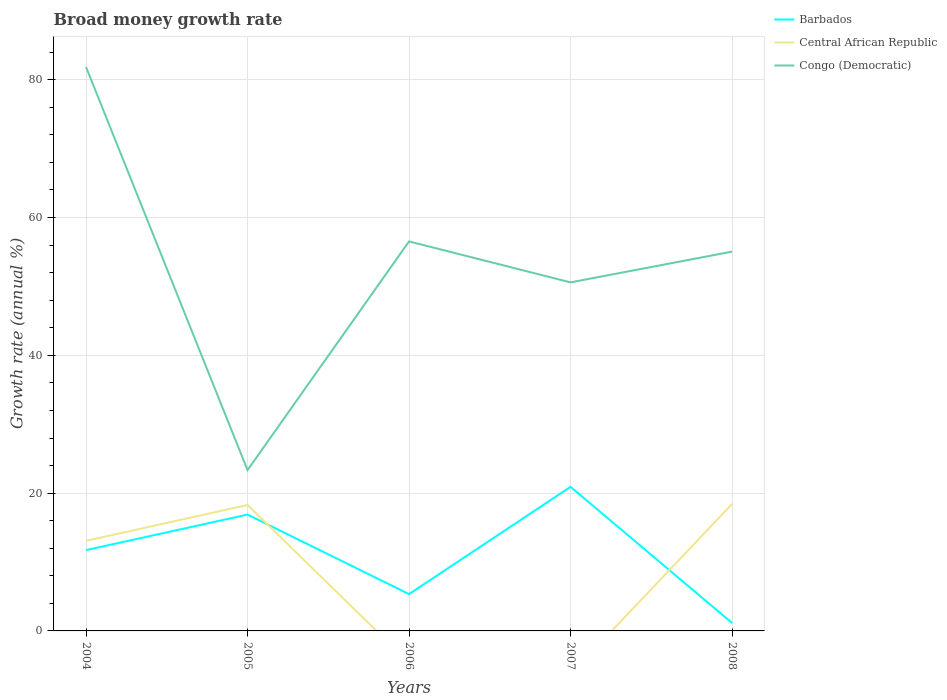How many different coloured lines are there?
Give a very brief answer. 3. Is the number of lines equal to the number of legend labels?
Keep it short and to the point. No. What is the total growth rate in Congo (Democratic) in the graph?
Offer a terse response. -27.25. What is the difference between the highest and the second highest growth rate in Congo (Democratic)?
Provide a succinct answer. 58.51. What is the difference between the highest and the lowest growth rate in Barbados?
Give a very brief answer. 3. Is the growth rate in Barbados strictly greater than the growth rate in Congo (Democratic) over the years?
Offer a very short reply. Yes. How many years are there in the graph?
Ensure brevity in your answer.  5. What is the difference between two consecutive major ticks on the Y-axis?
Your response must be concise. 20. Are the values on the major ticks of Y-axis written in scientific E-notation?
Offer a terse response. No. Does the graph contain any zero values?
Provide a short and direct response. Yes. Does the graph contain grids?
Your answer should be very brief. Yes. Where does the legend appear in the graph?
Your answer should be very brief. Top right. How many legend labels are there?
Give a very brief answer. 3. What is the title of the graph?
Offer a very short reply. Broad money growth rate. Does "Malaysia" appear as one of the legend labels in the graph?
Your response must be concise. No. What is the label or title of the Y-axis?
Make the answer very short. Growth rate (annual %). What is the Growth rate (annual %) in Barbados in 2004?
Keep it short and to the point. 11.73. What is the Growth rate (annual %) in Central African Republic in 2004?
Offer a terse response. 13.07. What is the Growth rate (annual %) in Congo (Democratic) in 2004?
Your response must be concise. 81.85. What is the Growth rate (annual %) in Barbados in 2005?
Give a very brief answer. 16.89. What is the Growth rate (annual %) of Central African Republic in 2005?
Your answer should be very brief. 18.28. What is the Growth rate (annual %) in Congo (Democratic) in 2005?
Keep it short and to the point. 23.34. What is the Growth rate (annual %) in Barbados in 2006?
Keep it short and to the point. 5.35. What is the Growth rate (annual %) of Congo (Democratic) in 2006?
Your answer should be compact. 56.53. What is the Growth rate (annual %) in Barbados in 2007?
Make the answer very short. 20.91. What is the Growth rate (annual %) of Central African Republic in 2007?
Give a very brief answer. 0. What is the Growth rate (annual %) in Congo (Democratic) in 2007?
Offer a terse response. 50.59. What is the Growth rate (annual %) in Barbados in 2008?
Provide a succinct answer. 1.15. What is the Growth rate (annual %) in Central African Republic in 2008?
Make the answer very short. 18.43. What is the Growth rate (annual %) of Congo (Democratic) in 2008?
Your response must be concise. 55.05. Across all years, what is the maximum Growth rate (annual %) of Barbados?
Offer a very short reply. 20.91. Across all years, what is the maximum Growth rate (annual %) in Central African Republic?
Your response must be concise. 18.43. Across all years, what is the maximum Growth rate (annual %) in Congo (Democratic)?
Provide a short and direct response. 81.85. Across all years, what is the minimum Growth rate (annual %) in Barbados?
Provide a short and direct response. 1.15. Across all years, what is the minimum Growth rate (annual %) in Central African Republic?
Make the answer very short. 0. Across all years, what is the minimum Growth rate (annual %) of Congo (Democratic)?
Provide a short and direct response. 23.34. What is the total Growth rate (annual %) of Barbados in the graph?
Make the answer very short. 56.03. What is the total Growth rate (annual %) of Central African Republic in the graph?
Provide a short and direct response. 49.79. What is the total Growth rate (annual %) of Congo (Democratic) in the graph?
Provide a succinct answer. 267.36. What is the difference between the Growth rate (annual %) in Barbados in 2004 and that in 2005?
Give a very brief answer. -5.16. What is the difference between the Growth rate (annual %) of Central African Republic in 2004 and that in 2005?
Offer a very short reply. -5.21. What is the difference between the Growth rate (annual %) in Congo (Democratic) in 2004 and that in 2005?
Provide a short and direct response. 58.51. What is the difference between the Growth rate (annual %) in Barbados in 2004 and that in 2006?
Ensure brevity in your answer.  6.38. What is the difference between the Growth rate (annual %) of Congo (Democratic) in 2004 and that in 2006?
Provide a short and direct response. 25.32. What is the difference between the Growth rate (annual %) of Barbados in 2004 and that in 2007?
Make the answer very short. -9.18. What is the difference between the Growth rate (annual %) of Congo (Democratic) in 2004 and that in 2007?
Make the answer very short. 31.27. What is the difference between the Growth rate (annual %) in Barbados in 2004 and that in 2008?
Provide a short and direct response. 10.58. What is the difference between the Growth rate (annual %) in Central African Republic in 2004 and that in 2008?
Ensure brevity in your answer.  -5.35. What is the difference between the Growth rate (annual %) in Congo (Democratic) in 2004 and that in 2008?
Your response must be concise. 26.8. What is the difference between the Growth rate (annual %) of Barbados in 2005 and that in 2006?
Give a very brief answer. 11.54. What is the difference between the Growth rate (annual %) in Congo (Democratic) in 2005 and that in 2006?
Ensure brevity in your answer.  -33.19. What is the difference between the Growth rate (annual %) in Barbados in 2005 and that in 2007?
Provide a succinct answer. -4.03. What is the difference between the Growth rate (annual %) in Congo (Democratic) in 2005 and that in 2007?
Make the answer very short. -27.25. What is the difference between the Growth rate (annual %) in Barbados in 2005 and that in 2008?
Provide a short and direct response. 15.73. What is the difference between the Growth rate (annual %) in Central African Republic in 2005 and that in 2008?
Your answer should be very brief. -0.14. What is the difference between the Growth rate (annual %) in Congo (Democratic) in 2005 and that in 2008?
Keep it short and to the point. -31.71. What is the difference between the Growth rate (annual %) in Barbados in 2006 and that in 2007?
Keep it short and to the point. -15.57. What is the difference between the Growth rate (annual %) of Congo (Democratic) in 2006 and that in 2007?
Ensure brevity in your answer.  5.94. What is the difference between the Growth rate (annual %) in Barbados in 2006 and that in 2008?
Your answer should be compact. 4.19. What is the difference between the Growth rate (annual %) in Congo (Democratic) in 2006 and that in 2008?
Provide a short and direct response. 1.48. What is the difference between the Growth rate (annual %) in Barbados in 2007 and that in 2008?
Keep it short and to the point. 19.76. What is the difference between the Growth rate (annual %) of Congo (Democratic) in 2007 and that in 2008?
Make the answer very short. -4.46. What is the difference between the Growth rate (annual %) in Barbados in 2004 and the Growth rate (annual %) in Central African Republic in 2005?
Keep it short and to the point. -6.55. What is the difference between the Growth rate (annual %) in Barbados in 2004 and the Growth rate (annual %) in Congo (Democratic) in 2005?
Ensure brevity in your answer.  -11.61. What is the difference between the Growth rate (annual %) in Central African Republic in 2004 and the Growth rate (annual %) in Congo (Democratic) in 2005?
Provide a short and direct response. -10.27. What is the difference between the Growth rate (annual %) in Barbados in 2004 and the Growth rate (annual %) in Congo (Democratic) in 2006?
Your answer should be compact. -44.8. What is the difference between the Growth rate (annual %) in Central African Republic in 2004 and the Growth rate (annual %) in Congo (Democratic) in 2006?
Provide a short and direct response. -43.46. What is the difference between the Growth rate (annual %) in Barbados in 2004 and the Growth rate (annual %) in Congo (Democratic) in 2007?
Make the answer very short. -38.86. What is the difference between the Growth rate (annual %) in Central African Republic in 2004 and the Growth rate (annual %) in Congo (Democratic) in 2007?
Your answer should be compact. -37.51. What is the difference between the Growth rate (annual %) of Barbados in 2004 and the Growth rate (annual %) of Central African Republic in 2008?
Give a very brief answer. -6.7. What is the difference between the Growth rate (annual %) of Barbados in 2004 and the Growth rate (annual %) of Congo (Democratic) in 2008?
Offer a terse response. -43.32. What is the difference between the Growth rate (annual %) in Central African Republic in 2004 and the Growth rate (annual %) in Congo (Democratic) in 2008?
Provide a succinct answer. -41.98. What is the difference between the Growth rate (annual %) of Barbados in 2005 and the Growth rate (annual %) of Congo (Democratic) in 2006?
Provide a short and direct response. -39.64. What is the difference between the Growth rate (annual %) in Central African Republic in 2005 and the Growth rate (annual %) in Congo (Democratic) in 2006?
Your response must be concise. -38.25. What is the difference between the Growth rate (annual %) in Barbados in 2005 and the Growth rate (annual %) in Congo (Democratic) in 2007?
Offer a terse response. -33.7. What is the difference between the Growth rate (annual %) of Central African Republic in 2005 and the Growth rate (annual %) of Congo (Democratic) in 2007?
Provide a short and direct response. -32.3. What is the difference between the Growth rate (annual %) in Barbados in 2005 and the Growth rate (annual %) in Central African Republic in 2008?
Offer a very short reply. -1.54. What is the difference between the Growth rate (annual %) in Barbados in 2005 and the Growth rate (annual %) in Congo (Democratic) in 2008?
Make the answer very short. -38.16. What is the difference between the Growth rate (annual %) in Central African Republic in 2005 and the Growth rate (annual %) in Congo (Democratic) in 2008?
Provide a succinct answer. -36.77. What is the difference between the Growth rate (annual %) of Barbados in 2006 and the Growth rate (annual %) of Congo (Democratic) in 2007?
Give a very brief answer. -45.24. What is the difference between the Growth rate (annual %) of Barbados in 2006 and the Growth rate (annual %) of Central African Republic in 2008?
Ensure brevity in your answer.  -13.08. What is the difference between the Growth rate (annual %) of Barbados in 2006 and the Growth rate (annual %) of Congo (Democratic) in 2008?
Keep it short and to the point. -49.71. What is the difference between the Growth rate (annual %) of Barbados in 2007 and the Growth rate (annual %) of Central African Republic in 2008?
Your answer should be very brief. 2.48. What is the difference between the Growth rate (annual %) in Barbados in 2007 and the Growth rate (annual %) in Congo (Democratic) in 2008?
Make the answer very short. -34.14. What is the average Growth rate (annual %) in Barbados per year?
Your answer should be compact. 11.21. What is the average Growth rate (annual %) in Central African Republic per year?
Give a very brief answer. 9.96. What is the average Growth rate (annual %) in Congo (Democratic) per year?
Give a very brief answer. 53.47. In the year 2004, what is the difference between the Growth rate (annual %) of Barbados and Growth rate (annual %) of Central African Republic?
Ensure brevity in your answer.  -1.35. In the year 2004, what is the difference between the Growth rate (annual %) in Barbados and Growth rate (annual %) in Congo (Democratic)?
Offer a very short reply. -70.12. In the year 2004, what is the difference between the Growth rate (annual %) of Central African Republic and Growth rate (annual %) of Congo (Democratic)?
Make the answer very short. -68.78. In the year 2005, what is the difference between the Growth rate (annual %) of Barbados and Growth rate (annual %) of Central African Republic?
Give a very brief answer. -1.4. In the year 2005, what is the difference between the Growth rate (annual %) in Barbados and Growth rate (annual %) in Congo (Democratic)?
Your answer should be compact. -6.46. In the year 2005, what is the difference between the Growth rate (annual %) of Central African Republic and Growth rate (annual %) of Congo (Democratic)?
Ensure brevity in your answer.  -5.06. In the year 2006, what is the difference between the Growth rate (annual %) in Barbados and Growth rate (annual %) in Congo (Democratic)?
Your answer should be compact. -51.19. In the year 2007, what is the difference between the Growth rate (annual %) in Barbados and Growth rate (annual %) in Congo (Democratic)?
Your answer should be compact. -29.67. In the year 2008, what is the difference between the Growth rate (annual %) of Barbados and Growth rate (annual %) of Central African Republic?
Keep it short and to the point. -17.27. In the year 2008, what is the difference between the Growth rate (annual %) in Barbados and Growth rate (annual %) in Congo (Democratic)?
Your answer should be very brief. -53.9. In the year 2008, what is the difference between the Growth rate (annual %) in Central African Republic and Growth rate (annual %) in Congo (Democratic)?
Offer a terse response. -36.62. What is the ratio of the Growth rate (annual %) in Barbados in 2004 to that in 2005?
Your answer should be compact. 0.69. What is the ratio of the Growth rate (annual %) in Central African Republic in 2004 to that in 2005?
Provide a short and direct response. 0.72. What is the ratio of the Growth rate (annual %) of Congo (Democratic) in 2004 to that in 2005?
Make the answer very short. 3.51. What is the ratio of the Growth rate (annual %) of Barbados in 2004 to that in 2006?
Ensure brevity in your answer.  2.19. What is the ratio of the Growth rate (annual %) of Congo (Democratic) in 2004 to that in 2006?
Your answer should be compact. 1.45. What is the ratio of the Growth rate (annual %) of Barbados in 2004 to that in 2007?
Give a very brief answer. 0.56. What is the ratio of the Growth rate (annual %) in Congo (Democratic) in 2004 to that in 2007?
Keep it short and to the point. 1.62. What is the ratio of the Growth rate (annual %) in Barbados in 2004 to that in 2008?
Keep it short and to the point. 10.16. What is the ratio of the Growth rate (annual %) of Central African Republic in 2004 to that in 2008?
Offer a terse response. 0.71. What is the ratio of the Growth rate (annual %) of Congo (Democratic) in 2004 to that in 2008?
Your response must be concise. 1.49. What is the ratio of the Growth rate (annual %) in Barbados in 2005 to that in 2006?
Make the answer very short. 3.16. What is the ratio of the Growth rate (annual %) in Congo (Democratic) in 2005 to that in 2006?
Offer a very short reply. 0.41. What is the ratio of the Growth rate (annual %) in Barbados in 2005 to that in 2007?
Keep it short and to the point. 0.81. What is the ratio of the Growth rate (annual %) of Congo (Democratic) in 2005 to that in 2007?
Give a very brief answer. 0.46. What is the ratio of the Growth rate (annual %) in Barbados in 2005 to that in 2008?
Give a very brief answer. 14.63. What is the ratio of the Growth rate (annual %) of Central African Republic in 2005 to that in 2008?
Make the answer very short. 0.99. What is the ratio of the Growth rate (annual %) in Congo (Democratic) in 2005 to that in 2008?
Make the answer very short. 0.42. What is the ratio of the Growth rate (annual %) of Barbados in 2006 to that in 2007?
Make the answer very short. 0.26. What is the ratio of the Growth rate (annual %) in Congo (Democratic) in 2006 to that in 2007?
Make the answer very short. 1.12. What is the ratio of the Growth rate (annual %) of Barbados in 2006 to that in 2008?
Provide a short and direct response. 4.63. What is the ratio of the Growth rate (annual %) in Congo (Democratic) in 2006 to that in 2008?
Your response must be concise. 1.03. What is the ratio of the Growth rate (annual %) of Barbados in 2007 to that in 2008?
Provide a succinct answer. 18.12. What is the ratio of the Growth rate (annual %) in Congo (Democratic) in 2007 to that in 2008?
Provide a short and direct response. 0.92. What is the difference between the highest and the second highest Growth rate (annual %) in Barbados?
Offer a terse response. 4.03. What is the difference between the highest and the second highest Growth rate (annual %) in Central African Republic?
Keep it short and to the point. 0.14. What is the difference between the highest and the second highest Growth rate (annual %) in Congo (Democratic)?
Your response must be concise. 25.32. What is the difference between the highest and the lowest Growth rate (annual %) of Barbados?
Keep it short and to the point. 19.76. What is the difference between the highest and the lowest Growth rate (annual %) of Central African Republic?
Provide a short and direct response. 18.43. What is the difference between the highest and the lowest Growth rate (annual %) in Congo (Democratic)?
Your answer should be very brief. 58.51. 